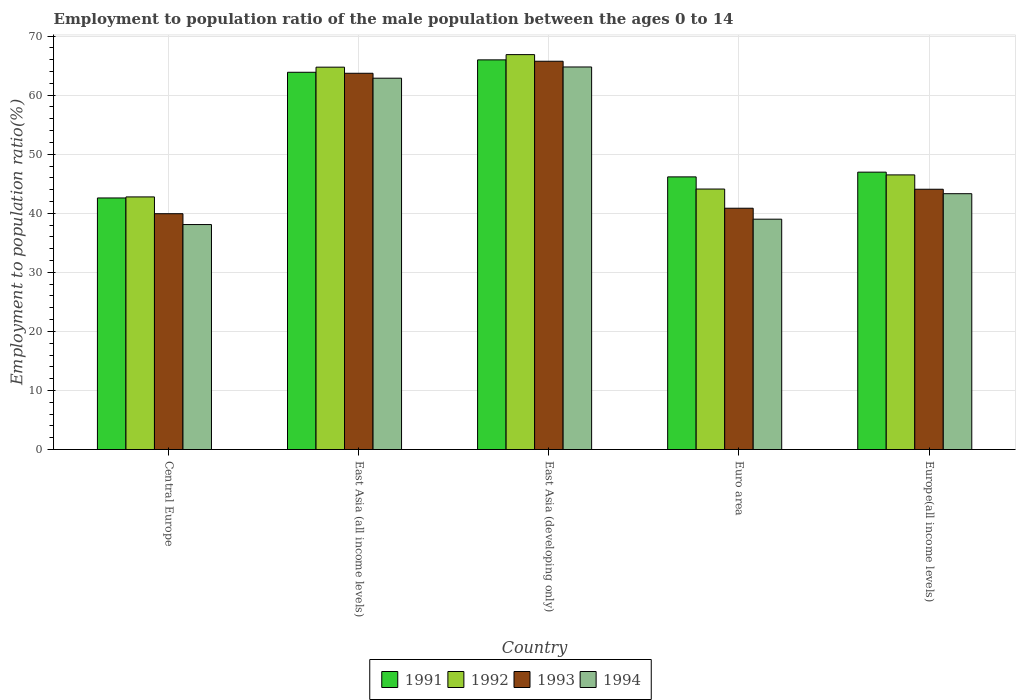How many bars are there on the 1st tick from the left?
Make the answer very short. 4. What is the label of the 4th group of bars from the left?
Your answer should be compact. Euro area. In how many cases, is the number of bars for a given country not equal to the number of legend labels?
Your answer should be compact. 0. What is the employment to population ratio in 1993 in Central Europe?
Your answer should be very brief. 39.93. Across all countries, what is the maximum employment to population ratio in 1993?
Make the answer very short. 65.75. Across all countries, what is the minimum employment to population ratio in 1992?
Offer a terse response. 42.77. In which country was the employment to population ratio in 1991 maximum?
Ensure brevity in your answer.  East Asia (developing only). In which country was the employment to population ratio in 1992 minimum?
Make the answer very short. Central Europe. What is the total employment to population ratio in 1991 in the graph?
Ensure brevity in your answer.  265.59. What is the difference between the employment to population ratio in 1994 in East Asia (all income levels) and that in Euro area?
Your answer should be very brief. 23.87. What is the difference between the employment to population ratio in 1992 in Central Europe and the employment to population ratio in 1993 in East Asia (developing only)?
Offer a terse response. -22.97. What is the average employment to population ratio in 1994 per country?
Make the answer very short. 49.61. What is the difference between the employment to population ratio of/in 1992 and employment to population ratio of/in 1994 in East Asia (all income levels)?
Provide a short and direct response. 1.87. What is the ratio of the employment to population ratio in 1992 in Central Europe to that in Europe(all income levels)?
Provide a short and direct response. 0.92. Is the difference between the employment to population ratio in 1992 in Euro area and Europe(all income levels) greater than the difference between the employment to population ratio in 1994 in Euro area and Europe(all income levels)?
Your answer should be compact. Yes. What is the difference between the highest and the second highest employment to population ratio in 1994?
Offer a very short reply. 21.46. What is the difference between the highest and the lowest employment to population ratio in 1992?
Make the answer very short. 24.09. In how many countries, is the employment to population ratio in 1991 greater than the average employment to population ratio in 1991 taken over all countries?
Your response must be concise. 2. Is the sum of the employment to population ratio in 1991 in Central Europe and Euro area greater than the maximum employment to population ratio in 1992 across all countries?
Your answer should be very brief. Yes. What does the 3rd bar from the left in East Asia (developing only) represents?
Your answer should be compact. 1993. Are all the bars in the graph horizontal?
Your response must be concise. No. How many countries are there in the graph?
Offer a very short reply. 5. What is the difference between two consecutive major ticks on the Y-axis?
Provide a succinct answer. 10. Are the values on the major ticks of Y-axis written in scientific E-notation?
Your answer should be very brief. No. Does the graph contain any zero values?
Ensure brevity in your answer.  No. Does the graph contain grids?
Your answer should be very brief. Yes. How are the legend labels stacked?
Offer a very short reply. Horizontal. What is the title of the graph?
Provide a succinct answer. Employment to population ratio of the male population between the ages 0 to 14. Does "2001" appear as one of the legend labels in the graph?
Ensure brevity in your answer.  No. What is the label or title of the X-axis?
Provide a succinct answer. Country. What is the label or title of the Y-axis?
Your answer should be very brief. Employment to population ratio(%). What is the Employment to population ratio(%) in 1991 in Central Europe?
Ensure brevity in your answer.  42.6. What is the Employment to population ratio(%) in 1992 in Central Europe?
Your answer should be compact. 42.77. What is the Employment to population ratio(%) in 1993 in Central Europe?
Provide a succinct answer. 39.93. What is the Employment to population ratio(%) in 1994 in Central Europe?
Provide a short and direct response. 38.09. What is the Employment to population ratio(%) of 1991 in East Asia (all income levels)?
Provide a short and direct response. 63.88. What is the Employment to population ratio(%) in 1992 in East Asia (all income levels)?
Provide a short and direct response. 64.74. What is the Employment to population ratio(%) in 1993 in East Asia (all income levels)?
Offer a terse response. 63.71. What is the Employment to population ratio(%) in 1994 in East Asia (all income levels)?
Give a very brief answer. 62.87. What is the Employment to population ratio(%) in 1991 in East Asia (developing only)?
Your answer should be very brief. 65.98. What is the Employment to population ratio(%) of 1992 in East Asia (developing only)?
Provide a short and direct response. 66.87. What is the Employment to population ratio(%) of 1993 in East Asia (developing only)?
Keep it short and to the point. 65.75. What is the Employment to population ratio(%) in 1994 in East Asia (developing only)?
Offer a very short reply. 64.78. What is the Employment to population ratio(%) of 1991 in Euro area?
Offer a very short reply. 46.17. What is the Employment to population ratio(%) of 1992 in Euro area?
Provide a succinct answer. 44.11. What is the Employment to population ratio(%) of 1993 in Euro area?
Ensure brevity in your answer.  40.86. What is the Employment to population ratio(%) of 1994 in Euro area?
Offer a very short reply. 39. What is the Employment to population ratio(%) in 1991 in Europe(all income levels)?
Your answer should be very brief. 46.97. What is the Employment to population ratio(%) in 1992 in Europe(all income levels)?
Provide a short and direct response. 46.5. What is the Employment to population ratio(%) in 1993 in Europe(all income levels)?
Provide a short and direct response. 44.07. What is the Employment to population ratio(%) in 1994 in Europe(all income levels)?
Your response must be concise. 43.32. Across all countries, what is the maximum Employment to population ratio(%) of 1991?
Give a very brief answer. 65.98. Across all countries, what is the maximum Employment to population ratio(%) in 1992?
Make the answer very short. 66.87. Across all countries, what is the maximum Employment to population ratio(%) in 1993?
Ensure brevity in your answer.  65.75. Across all countries, what is the maximum Employment to population ratio(%) in 1994?
Keep it short and to the point. 64.78. Across all countries, what is the minimum Employment to population ratio(%) in 1991?
Your answer should be very brief. 42.6. Across all countries, what is the minimum Employment to population ratio(%) of 1992?
Your answer should be compact. 42.77. Across all countries, what is the minimum Employment to population ratio(%) in 1993?
Give a very brief answer. 39.93. Across all countries, what is the minimum Employment to population ratio(%) of 1994?
Provide a succinct answer. 38.09. What is the total Employment to population ratio(%) of 1991 in the graph?
Give a very brief answer. 265.59. What is the total Employment to population ratio(%) of 1992 in the graph?
Make the answer very short. 264.99. What is the total Employment to population ratio(%) of 1993 in the graph?
Your answer should be very brief. 254.31. What is the total Employment to population ratio(%) of 1994 in the graph?
Offer a very short reply. 248.06. What is the difference between the Employment to population ratio(%) of 1991 in Central Europe and that in East Asia (all income levels)?
Ensure brevity in your answer.  -21.28. What is the difference between the Employment to population ratio(%) of 1992 in Central Europe and that in East Asia (all income levels)?
Your response must be concise. -21.97. What is the difference between the Employment to population ratio(%) in 1993 in Central Europe and that in East Asia (all income levels)?
Make the answer very short. -23.78. What is the difference between the Employment to population ratio(%) of 1994 in Central Europe and that in East Asia (all income levels)?
Provide a succinct answer. -24.78. What is the difference between the Employment to population ratio(%) of 1991 in Central Europe and that in East Asia (developing only)?
Your response must be concise. -23.38. What is the difference between the Employment to population ratio(%) in 1992 in Central Europe and that in East Asia (developing only)?
Offer a very short reply. -24.09. What is the difference between the Employment to population ratio(%) in 1993 in Central Europe and that in East Asia (developing only)?
Ensure brevity in your answer.  -25.82. What is the difference between the Employment to population ratio(%) in 1994 in Central Europe and that in East Asia (developing only)?
Your answer should be compact. -26.68. What is the difference between the Employment to population ratio(%) of 1991 in Central Europe and that in Euro area?
Your answer should be compact. -3.57. What is the difference between the Employment to population ratio(%) in 1992 in Central Europe and that in Euro area?
Provide a short and direct response. -1.33. What is the difference between the Employment to population ratio(%) in 1993 in Central Europe and that in Euro area?
Keep it short and to the point. -0.93. What is the difference between the Employment to population ratio(%) of 1994 in Central Europe and that in Euro area?
Provide a succinct answer. -0.91. What is the difference between the Employment to population ratio(%) of 1991 in Central Europe and that in Europe(all income levels)?
Offer a very short reply. -4.37. What is the difference between the Employment to population ratio(%) in 1992 in Central Europe and that in Europe(all income levels)?
Your answer should be very brief. -3.73. What is the difference between the Employment to population ratio(%) in 1993 in Central Europe and that in Europe(all income levels)?
Your answer should be compact. -4.14. What is the difference between the Employment to population ratio(%) in 1994 in Central Europe and that in Europe(all income levels)?
Keep it short and to the point. -5.23. What is the difference between the Employment to population ratio(%) in 1991 in East Asia (all income levels) and that in East Asia (developing only)?
Keep it short and to the point. -2.1. What is the difference between the Employment to population ratio(%) in 1992 in East Asia (all income levels) and that in East Asia (developing only)?
Your response must be concise. -2.12. What is the difference between the Employment to population ratio(%) of 1993 in East Asia (all income levels) and that in East Asia (developing only)?
Provide a succinct answer. -2.04. What is the difference between the Employment to population ratio(%) of 1994 in East Asia (all income levels) and that in East Asia (developing only)?
Make the answer very short. -1.9. What is the difference between the Employment to population ratio(%) in 1991 in East Asia (all income levels) and that in Euro area?
Provide a short and direct response. 17.71. What is the difference between the Employment to population ratio(%) in 1992 in East Asia (all income levels) and that in Euro area?
Your answer should be compact. 20.64. What is the difference between the Employment to population ratio(%) in 1993 in East Asia (all income levels) and that in Euro area?
Ensure brevity in your answer.  22.85. What is the difference between the Employment to population ratio(%) in 1994 in East Asia (all income levels) and that in Euro area?
Provide a short and direct response. 23.87. What is the difference between the Employment to population ratio(%) of 1991 in East Asia (all income levels) and that in Europe(all income levels)?
Provide a succinct answer. 16.91. What is the difference between the Employment to population ratio(%) in 1992 in East Asia (all income levels) and that in Europe(all income levels)?
Give a very brief answer. 18.24. What is the difference between the Employment to population ratio(%) in 1993 in East Asia (all income levels) and that in Europe(all income levels)?
Offer a very short reply. 19.64. What is the difference between the Employment to population ratio(%) in 1994 in East Asia (all income levels) and that in Europe(all income levels)?
Offer a terse response. 19.56. What is the difference between the Employment to population ratio(%) of 1991 in East Asia (developing only) and that in Euro area?
Make the answer very short. 19.81. What is the difference between the Employment to population ratio(%) in 1992 in East Asia (developing only) and that in Euro area?
Your answer should be very brief. 22.76. What is the difference between the Employment to population ratio(%) in 1993 in East Asia (developing only) and that in Euro area?
Keep it short and to the point. 24.89. What is the difference between the Employment to population ratio(%) in 1994 in East Asia (developing only) and that in Euro area?
Keep it short and to the point. 25.77. What is the difference between the Employment to population ratio(%) in 1991 in East Asia (developing only) and that in Europe(all income levels)?
Make the answer very short. 19.01. What is the difference between the Employment to population ratio(%) in 1992 in East Asia (developing only) and that in Europe(all income levels)?
Your answer should be compact. 20.37. What is the difference between the Employment to population ratio(%) of 1993 in East Asia (developing only) and that in Europe(all income levels)?
Your response must be concise. 21.67. What is the difference between the Employment to population ratio(%) in 1994 in East Asia (developing only) and that in Europe(all income levels)?
Offer a very short reply. 21.46. What is the difference between the Employment to population ratio(%) in 1991 in Euro area and that in Europe(all income levels)?
Keep it short and to the point. -0.8. What is the difference between the Employment to population ratio(%) in 1992 in Euro area and that in Europe(all income levels)?
Provide a succinct answer. -2.39. What is the difference between the Employment to population ratio(%) in 1993 in Euro area and that in Europe(all income levels)?
Keep it short and to the point. -3.21. What is the difference between the Employment to population ratio(%) of 1994 in Euro area and that in Europe(all income levels)?
Make the answer very short. -4.31. What is the difference between the Employment to population ratio(%) of 1991 in Central Europe and the Employment to population ratio(%) of 1992 in East Asia (all income levels)?
Your answer should be very brief. -22.15. What is the difference between the Employment to population ratio(%) of 1991 in Central Europe and the Employment to population ratio(%) of 1993 in East Asia (all income levels)?
Offer a terse response. -21.11. What is the difference between the Employment to population ratio(%) of 1991 in Central Europe and the Employment to population ratio(%) of 1994 in East Asia (all income levels)?
Offer a very short reply. -20.28. What is the difference between the Employment to population ratio(%) in 1992 in Central Europe and the Employment to population ratio(%) in 1993 in East Asia (all income levels)?
Your answer should be compact. -20.94. What is the difference between the Employment to population ratio(%) of 1992 in Central Europe and the Employment to population ratio(%) of 1994 in East Asia (all income levels)?
Your response must be concise. -20.1. What is the difference between the Employment to population ratio(%) of 1993 in Central Europe and the Employment to population ratio(%) of 1994 in East Asia (all income levels)?
Your answer should be very brief. -22.95. What is the difference between the Employment to population ratio(%) of 1991 in Central Europe and the Employment to population ratio(%) of 1992 in East Asia (developing only)?
Ensure brevity in your answer.  -24.27. What is the difference between the Employment to population ratio(%) of 1991 in Central Europe and the Employment to population ratio(%) of 1993 in East Asia (developing only)?
Give a very brief answer. -23.15. What is the difference between the Employment to population ratio(%) in 1991 in Central Europe and the Employment to population ratio(%) in 1994 in East Asia (developing only)?
Ensure brevity in your answer.  -22.18. What is the difference between the Employment to population ratio(%) of 1992 in Central Europe and the Employment to population ratio(%) of 1993 in East Asia (developing only)?
Your answer should be very brief. -22.97. What is the difference between the Employment to population ratio(%) of 1992 in Central Europe and the Employment to population ratio(%) of 1994 in East Asia (developing only)?
Provide a succinct answer. -22. What is the difference between the Employment to population ratio(%) in 1993 in Central Europe and the Employment to population ratio(%) in 1994 in East Asia (developing only)?
Provide a succinct answer. -24.85. What is the difference between the Employment to population ratio(%) of 1991 in Central Europe and the Employment to population ratio(%) of 1992 in Euro area?
Ensure brevity in your answer.  -1.51. What is the difference between the Employment to population ratio(%) in 1991 in Central Europe and the Employment to population ratio(%) in 1993 in Euro area?
Provide a succinct answer. 1.74. What is the difference between the Employment to population ratio(%) in 1991 in Central Europe and the Employment to population ratio(%) in 1994 in Euro area?
Your answer should be compact. 3.59. What is the difference between the Employment to population ratio(%) in 1992 in Central Europe and the Employment to population ratio(%) in 1993 in Euro area?
Offer a very short reply. 1.92. What is the difference between the Employment to population ratio(%) in 1992 in Central Europe and the Employment to population ratio(%) in 1994 in Euro area?
Offer a terse response. 3.77. What is the difference between the Employment to population ratio(%) in 1993 in Central Europe and the Employment to population ratio(%) in 1994 in Euro area?
Offer a terse response. 0.92. What is the difference between the Employment to population ratio(%) in 1991 in Central Europe and the Employment to population ratio(%) in 1992 in Europe(all income levels)?
Ensure brevity in your answer.  -3.9. What is the difference between the Employment to population ratio(%) of 1991 in Central Europe and the Employment to population ratio(%) of 1993 in Europe(all income levels)?
Your answer should be compact. -1.47. What is the difference between the Employment to population ratio(%) in 1991 in Central Europe and the Employment to population ratio(%) in 1994 in Europe(all income levels)?
Offer a terse response. -0.72. What is the difference between the Employment to population ratio(%) in 1992 in Central Europe and the Employment to population ratio(%) in 1993 in Europe(all income levels)?
Your answer should be very brief. -1.3. What is the difference between the Employment to population ratio(%) in 1992 in Central Europe and the Employment to population ratio(%) in 1994 in Europe(all income levels)?
Ensure brevity in your answer.  -0.55. What is the difference between the Employment to population ratio(%) of 1993 in Central Europe and the Employment to population ratio(%) of 1994 in Europe(all income levels)?
Provide a succinct answer. -3.39. What is the difference between the Employment to population ratio(%) in 1991 in East Asia (all income levels) and the Employment to population ratio(%) in 1992 in East Asia (developing only)?
Your answer should be very brief. -2.99. What is the difference between the Employment to population ratio(%) of 1991 in East Asia (all income levels) and the Employment to population ratio(%) of 1993 in East Asia (developing only)?
Give a very brief answer. -1.87. What is the difference between the Employment to population ratio(%) of 1991 in East Asia (all income levels) and the Employment to population ratio(%) of 1994 in East Asia (developing only)?
Offer a terse response. -0.9. What is the difference between the Employment to population ratio(%) of 1992 in East Asia (all income levels) and the Employment to population ratio(%) of 1993 in East Asia (developing only)?
Make the answer very short. -1. What is the difference between the Employment to population ratio(%) in 1992 in East Asia (all income levels) and the Employment to population ratio(%) in 1994 in East Asia (developing only)?
Make the answer very short. -0.03. What is the difference between the Employment to population ratio(%) of 1993 in East Asia (all income levels) and the Employment to population ratio(%) of 1994 in East Asia (developing only)?
Ensure brevity in your answer.  -1.07. What is the difference between the Employment to population ratio(%) of 1991 in East Asia (all income levels) and the Employment to population ratio(%) of 1992 in Euro area?
Your response must be concise. 19.77. What is the difference between the Employment to population ratio(%) in 1991 in East Asia (all income levels) and the Employment to population ratio(%) in 1993 in Euro area?
Offer a terse response. 23.02. What is the difference between the Employment to population ratio(%) of 1991 in East Asia (all income levels) and the Employment to population ratio(%) of 1994 in Euro area?
Your answer should be compact. 24.87. What is the difference between the Employment to population ratio(%) of 1992 in East Asia (all income levels) and the Employment to population ratio(%) of 1993 in Euro area?
Make the answer very short. 23.89. What is the difference between the Employment to population ratio(%) in 1992 in East Asia (all income levels) and the Employment to population ratio(%) in 1994 in Euro area?
Your response must be concise. 25.74. What is the difference between the Employment to population ratio(%) in 1993 in East Asia (all income levels) and the Employment to population ratio(%) in 1994 in Euro area?
Keep it short and to the point. 24.7. What is the difference between the Employment to population ratio(%) of 1991 in East Asia (all income levels) and the Employment to population ratio(%) of 1992 in Europe(all income levels)?
Offer a terse response. 17.38. What is the difference between the Employment to population ratio(%) of 1991 in East Asia (all income levels) and the Employment to population ratio(%) of 1993 in Europe(all income levels)?
Your answer should be compact. 19.81. What is the difference between the Employment to population ratio(%) of 1991 in East Asia (all income levels) and the Employment to population ratio(%) of 1994 in Europe(all income levels)?
Offer a very short reply. 20.56. What is the difference between the Employment to population ratio(%) in 1992 in East Asia (all income levels) and the Employment to population ratio(%) in 1993 in Europe(all income levels)?
Your response must be concise. 20.67. What is the difference between the Employment to population ratio(%) of 1992 in East Asia (all income levels) and the Employment to population ratio(%) of 1994 in Europe(all income levels)?
Give a very brief answer. 21.43. What is the difference between the Employment to population ratio(%) of 1993 in East Asia (all income levels) and the Employment to population ratio(%) of 1994 in Europe(all income levels)?
Your answer should be compact. 20.39. What is the difference between the Employment to population ratio(%) in 1991 in East Asia (developing only) and the Employment to population ratio(%) in 1992 in Euro area?
Provide a succinct answer. 21.87. What is the difference between the Employment to population ratio(%) of 1991 in East Asia (developing only) and the Employment to population ratio(%) of 1993 in Euro area?
Keep it short and to the point. 25.12. What is the difference between the Employment to population ratio(%) in 1991 in East Asia (developing only) and the Employment to population ratio(%) in 1994 in Euro area?
Keep it short and to the point. 26.98. What is the difference between the Employment to population ratio(%) in 1992 in East Asia (developing only) and the Employment to population ratio(%) in 1993 in Euro area?
Give a very brief answer. 26.01. What is the difference between the Employment to population ratio(%) of 1992 in East Asia (developing only) and the Employment to population ratio(%) of 1994 in Euro area?
Provide a short and direct response. 27.86. What is the difference between the Employment to population ratio(%) of 1993 in East Asia (developing only) and the Employment to population ratio(%) of 1994 in Euro area?
Provide a short and direct response. 26.74. What is the difference between the Employment to population ratio(%) of 1991 in East Asia (developing only) and the Employment to population ratio(%) of 1992 in Europe(all income levels)?
Offer a terse response. 19.48. What is the difference between the Employment to population ratio(%) in 1991 in East Asia (developing only) and the Employment to population ratio(%) in 1993 in Europe(all income levels)?
Make the answer very short. 21.91. What is the difference between the Employment to population ratio(%) of 1991 in East Asia (developing only) and the Employment to population ratio(%) of 1994 in Europe(all income levels)?
Offer a terse response. 22.66. What is the difference between the Employment to population ratio(%) of 1992 in East Asia (developing only) and the Employment to population ratio(%) of 1993 in Europe(all income levels)?
Give a very brief answer. 22.8. What is the difference between the Employment to population ratio(%) of 1992 in East Asia (developing only) and the Employment to population ratio(%) of 1994 in Europe(all income levels)?
Your answer should be very brief. 23.55. What is the difference between the Employment to population ratio(%) in 1993 in East Asia (developing only) and the Employment to population ratio(%) in 1994 in Europe(all income levels)?
Give a very brief answer. 22.43. What is the difference between the Employment to population ratio(%) of 1991 in Euro area and the Employment to population ratio(%) of 1992 in Europe(all income levels)?
Make the answer very short. -0.33. What is the difference between the Employment to population ratio(%) of 1991 in Euro area and the Employment to population ratio(%) of 1993 in Europe(all income levels)?
Ensure brevity in your answer.  2.09. What is the difference between the Employment to population ratio(%) in 1991 in Euro area and the Employment to population ratio(%) in 1994 in Europe(all income levels)?
Provide a short and direct response. 2.85. What is the difference between the Employment to population ratio(%) of 1992 in Euro area and the Employment to population ratio(%) of 1993 in Europe(all income levels)?
Provide a short and direct response. 0.03. What is the difference between the Employment to population ratio(%) of 1992 in Euro area and the Employment to population ratio(%) of 1994 in Europe(all income levels)?
Your response must be concise. 0.79. What is the difference between the Employment to population ratio(%) of 1993 in Euro area and the Employment to population ratio(%) of 1994 in Europe(all income levels)?
Provide a succinct answer. -2.46. What is the average Employment to population ratio(%) in 1991 per country?
Ensure brevity in your answer.  53.12. What is the average Employment to population ratio(%) in 1992 per country?
Provide a short and direct response. 53. What is the average Employment to population ratio(%) in 1993 per country?
Your response must be concise. 50.86. What is the average Employment to population ratio(%) of 1994 per country?
Provide a succinct answer. 49.61. What is the difference between the Employment to population ratio(%) in 1991 and Employment to population ratio(%) in 1992 in Central Europe?
Make the answer very short. -0.18. What is the difference between the Employment to population ratio(%) in 1991 and Employment to population ratio(%) in 1993 in Central Europe?
Your response must be concise. 2.67. What is the difference between the Employment to population ratio(%) of 1991 and Employment to population ratio(%) of 1994 in Central Europe?
Your response must be concise. 4.5. What is the difference between the Employment to population ratio(%) in 1992 and Employment to population ratio(%) in 1993 in Central Europe?
Your response must be concise. 2.84. What is the difference between the Employment to population ratio(%) in 1992 and Employment to population ratio(%) in 1994 in Central Europe?
Make the answer very short. 4.68. What is the difference between the Employment to population ratio(%) of 1993 and Employment to population ratio(%) of 1994 in Central Europe?
Your answer should be compact. 1.84. What is the difference between the Employment to population ratio(%) in 1991 and Employment to population ratio(%) in 1992 in East Asia (all income levels)?
Ensure brevity in your answer.  -0.87. What is the difference between the Employment to population ratio(%) in 1991 and Employment to population ratio(%) in 1993 in East Asia (all income levels)?
Keep it short and to the point. 0.17. What is the difference between the Employment to population ratio(%) of 1992 and Employment to population ratio(%) of 1994 in East Asia (all income levels)?
Ensure brevity in your answer.  1.87. What is the difference between the Employment to population ratio(%) in 1993 and Employment to population ratio(%) in 1994 in East Asia (all income levels)?
Offer a very short reply. 0.83. What is the difference between the Employment to population ratio(%) in 1991 and Employment to population ratio(%) in 1992 in East Asia (developing only)?
Your response must be concise. -0.89. What is the difference between the Employment to population ratio(%) of 1991 and Employment to population ratio(%) of 1993 in East Asia (developing only)?
Provide a succinct answer. 0.23. What is the difference between the Employment to population ratio(%) in 1991 and Employment to population ratio(%) in 1994 in East Asia (developing only)?
Your response must be concise. 1.2. What is the difference between the Employment to population ratio(%) in 1992 and Employment to population ratio(%) in 1993 in East Asia (developing only)?
Make the answer very short. 1.12. What is the difference between the Employment to population ratio(%) of 1992 and Employment to population ratio(%) of 1994 in East Asia (developing only)?
Ensure brevity in your answer.  2.09. What is the difference between the Employment to population ratio(%) of 1993 and Employment to population ratio(%) of 1994 in East Asia (developing only)?
Offer a very short reply. 0.97. What is the difference between the Employment to population ratio(%) of 1991 and Employment to population ratio(%) of 1992 in Euro area?
Offer a very short reply. 2.06. What is the difference between the Employment to population ratio(%) in 1991 and Employment to population ratio(%) in 1993 in Euro area?
Offer a terse response. 5.31. What is the difference between the Employment to population ratio(%) of 1991 and Employment to population ratio(%) of 1994 in Euro area?
Your answer should be compact. 7.16. What is the difference between the Employment to population ratio(%) in 1992 and Employment to population ratio(%) in 1993 in Euro area?
Make the answer very short. 3.25. What is the difference between the Employment to population ratio(%) in 1992 and Employment to population ratio(%) in 1994 in Euro area?
Ensure brevity in your answer.  5.1. What is the difference between the Employment to population ratio(%) of 1993 and Employment to population ratio(%) of 1994 in Euro area?
Keep it short and to the point. 1.85. What is the difference between the Employment to population ratio(%) in 1991 and Employment to population ratio(%) in 1992 in Europe(all income levels)?
Offer a very short reply. 0.47. What is the difference between the Employment to population ratio(%) of 1991 and Employment to population ratio(%) of 1993 in Europe(all income levels)?
Provide a succinct answer. 2.9. What is the difference between the Employment to population ratio(%) in 1991 and Employment to population ratio(%) in 1994 in Europe(all income levels)?
Your answer should be very brief. 3.65. What is the difference between the Employment to population ratio(%) in 1992 and Employment to population ratio(%) in 1993 in Europe(all income levels)?
Your response must be concise. 2.43. What is the difference between the Employment to population ratio(%) of 1992 and Employment to population ratio(%) of 1994 in Europe(all income levels)?
Offer a terse response. 3.18. What is the difference between the Employment to population ratio(%) of 1993 and Employment to population ratio(%) of 1994 in Europe(all income levels)?
Your response must be concise. 0.75. What is the ratio of the Employment to population ratio(%) in 1991 in Central Europe to that in East Asia (all income levels)?
Make the answer very short. 0.67. What is the ratio of the Employment to population ratio(%) in 1992 in Central Europe to that in East Asia (all income levels)?
Give a very brief answer. 0.66. What is the ratio of the Employment to population ratio(%) of 1993 in Central Europe to that in East Asia (all income levels)?
Offer a very short reply. 0.63. What is the ratio of the Employment to population ratio(%) of 1994 in Central Europe to that in East Asia (all income levels)?
Your answer should be very brief. 0.61. What is the ratio of the Employment to population ratio(%) in 1991 in Central Europe to that in East Asia (developing only)?
Your response must be concise. 0.65. What is the ratio of the Employment to population ratio(%) in 1992 in Central Europe to that in East Asia (developing only)?
Provide a succinct answer. 0.64. What is the ratio of the Employment to population ratio(%) in 1993 in Central Europe to that in East Asia (developing only)?
Keep it short and to the point. 0.61. What is the ratio of the Employment to population ratio(%) of 1994 in Central Europe to that in East Asia (developing only)?
Your answer should be compact. 0.59. What is the ratio of the Employment to population ratio(%) in 1991 in Central Europe to that in Euro area?
Provide a succinct answer. 0.92. What is the ratio of the Employment to population ratio(%) of 1992 in Central Europe to that in Euro area?
Ensure brevity in your answer.  0.97. What is the ratio of the Employment to population ratio(%) of 1993 in Central Europe to that in Euro area?
Offer a terse response. 0.98. What is the ratio of the Employment to population ratio(%) of 1994 in Central Europe to that in Euro area?
Make the answer very short. 0.98. What is the ratio of the Employment to population ratio(%) in 1991 in Central Europe to that in Europe(all income levels)?
Make the answer very short. 0.91. What is the ratio of the Employment to population ratio(%) in 1992 in Central Europe to that in Europe(all income levels)?
Keep it short and to the point. 0.92. What is the ratio of the Employment to population ratio(%) in 1993 in Central Europe to that in Europe(all income levels)?
Give a very brief answer. 0.91. What is the ratio of the Employment to population ratio(%) in 1994 in Central Europe to that in Europe(all income levels)?
Keep it short and to the point. 0.88. What is the ratio of the Employment to population ratio(%) in 1991 in East Asia (all income levels) to that in East Asia (developing only)?
Provide a short and direct response. 0.97. What is the ratio of the Employment to population ratio(%) of 1992 in East Asia (all income levels) to that in East Asia (developing only)?
Keep it short and to the point. 0.97. What is the ratio of the Employment to population ratio(%) of 1994 in East Asia (all income levels) to that in East Asia (developing only)?
Provide a short and direct response. 0.97. What is the ratio of the Employment to population ratio(%) of 1991 in East Asia (all income levels) to that in Euro area?
Make the answer very short. 1.38. What is the ratio of the Employment to population ratio(%) in 1992 in East Asia (all income levels) to that in Euro area?
Your answer should be compact. 1.47. What is the ratio of the Employment to population ratio(%) of 1993 in East Asia (all income levels) to that in Euro area?
Ensure brevity in your answer.  1.56. What is the ratio of the Employment to population ratio(%) in 1994 in East Asia (all income levels) to that in Euro area?
Keep it short and to the point. 1.61. What is the ratio of the Employment to population ratio(%) of 1991 in East Asia (all income levels) to that in Europe(all income levels)?
Provide a short and direct response. 1.36. What is the ratio of the Employment to population ratio(%) of 1992 in East Asia (all income levels) to that in Europe(all income levels)?
Your response must be concise. 1.39. What is the ratio of the Employment to population ratio(%) of 1993 in East Asia (all income levels) to that in Europe(all income levels)?
Provide a succinct answer. 1.45. What is the ratio of the Employment to population ratio(%) in 1994 in East Asia (all income levels) to that in Europe(all income levels)?
Ensure brevity in your answer.  1.45. What is the ratio of the Employment to population ratio(%) in 1991 in East Asia (developing only) to that in Euro area?
Make the answer very short. 1.43. What is the ratio of the Employment to population ratio(%) of 1992 in East Asia (developing only) to that in Euro area?
Keep it short and to the point. 1.52. What is the ratio of the Employment to population ratio(%) of 1993 in East Asia (developing only) to that in Euro area?
Your answer should be compact. 1.61. What is the ratio of the Employment to population ratio(%) of 1994 in East Asia (developing only) to that in Euro area?
Provide a short and direct response. 1.66. What is the ratio of the Employment to population ratio(%) of 1991 in East Asia (developing only) to that in Europe(all income levels)?
Provide a succinct answer. 1.4. What is the ratio of the Employment to population ratio(%) of 1992 in East Asia (developing only) to that in Europe(all income levels)?
Give a very brief answer. 1.44. What is the ratio of the Employment to population ratio(%) in 1993 in East Asia (developing only) to that in Europe(all income levels)?
Your response must be concise. 1.49. What is the ratio of the Employment to population ratio(%) of 1994 in East Asia (developing only) to that in Europe(all income levels)?
Give a very brief answer. 1.5. What is the ratio of the Employment to population ratio(%) in 1991 in Euro area to that in Europe(all income levels)?
Make the answer very short. 0.98. What is the ratio of the Employment to population ratio(%) in 1992 in Euro area to that in Europe(all income levels)?
Make the answer very short. 0.95. What is the ratio of the Employment to population ratio(%) of 1993 in Euro area to that in Europe(all income levels)?
Make the answer very short. 0.93. What is the ratio of the Employment to population ratio(%) of 1994 in Euro area to that in Europe(all income levels)?
Ensure brevity in your answer.  0.9. What is the difference between the highest and the second highest Employment to population ratio(%) of 1991?
Your answer should be compact. 2.1. What is the difference between the highest and the second highest Employment to population ratio(%) of 1992?
Your answer should be very brief. 2.12. What is the difference between the highest and the second highest Employment to population ratio(%) of 1993?
Make the answer very short. 2.04. What is the difference between the highest and the second highest Employment to population ratio(%) of 1994?
Your answer should be compact. 1.9. What is the difference between the highest and the lowest Employment to population ratio(%) in 1991?
Your answer should be compact. 23.38. What is the difference between the highest and the lowest Employment to population ratio(%) in 1992?
Your answer should be compact. 24.09. What is the difference between the highest and the lowest Employment to population ratio(%) in 1993?
Make the answer very short. 25.82. What is the difference between the highest and the lowest Employment to population ratio(%) of 1994?
Your response must be concise. 26.68. 